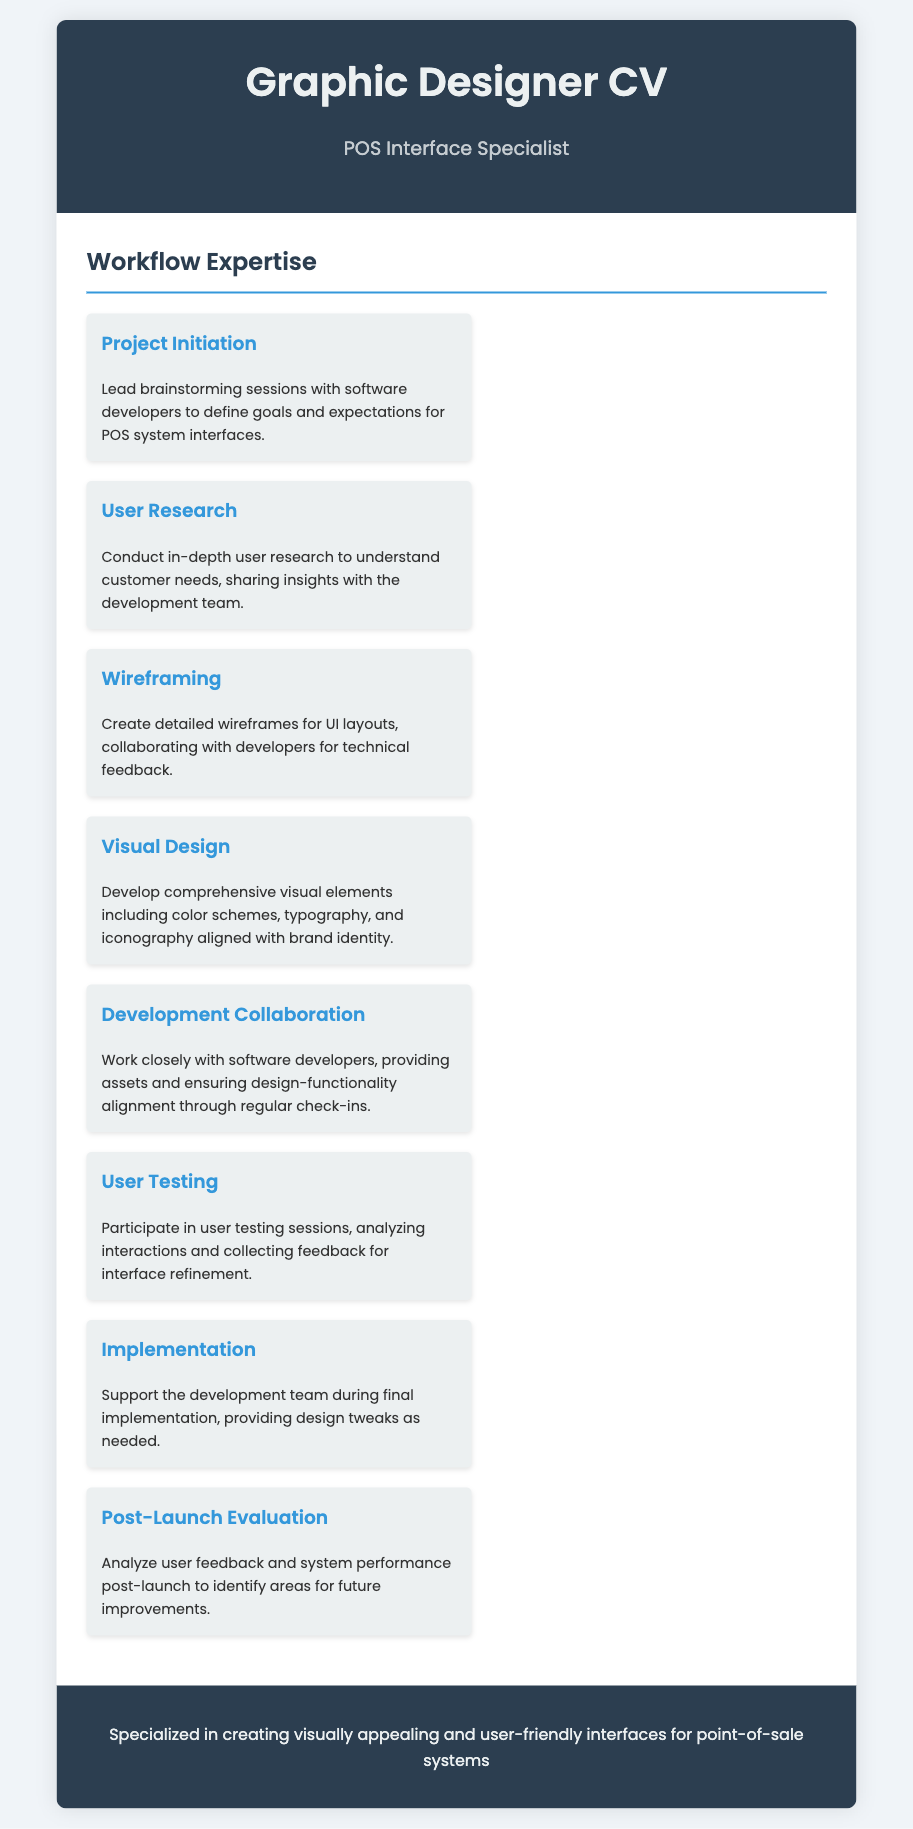what is the title of the CV? The title of the CV is specified in the document header.
Answer: Graphic Designer CV what is the subtitle mentioned? The subtitle indicates the area of specialization of the graphic designer in the document.
Answer: POS Interface Specialist how many workflow items are listed? The total number of workflow items can be counted from the document.
Answer: 8 which workflow item involves user feedback analysis? This item specifically mentions analyzing user interactions and collecting feedback related to interface improvements.
Answer: User Testing what is included in the visual design process? The visual design process covers specific elements related to branding as mentioned in the workflow item.
Answer: color schemes, typography, and iconography who should be involved in project initiation sessions? The document states who leads the discussions in the project initiation stage.
Answer: software developers what follows after the implementation stage in the workflow? This stage relates to assessing the outcome of the project after it has been launched.
Answer: Post-Launch Evaluation which item emphasizes collaboration with developers? This item highlights the importance of working together with the development team throughout the process.
Answer: Development Collaboration 